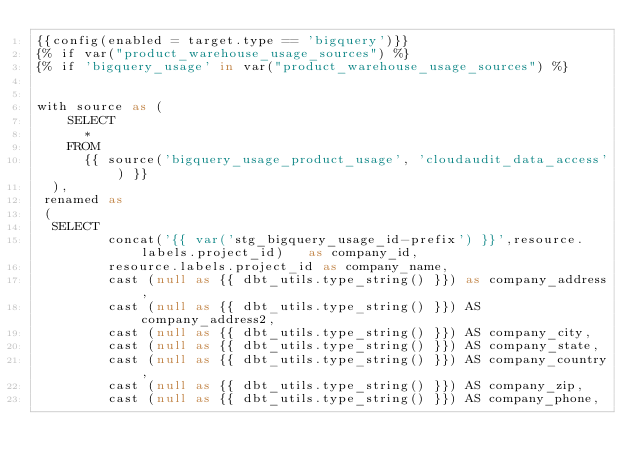<code> <loc_0><loc_0><loc_500><loc_500><_SQL_>{{config(enabled = target.type == 'bigquery')}}
{% if var("product_warehouse_usage_sources") %}
{% if 'bigquery_usage' in var("product_warehouse_usage_sources") %}


with source as (
    SELECT
      *
    FROM
      {{ source('bigquery_usage_product_usage', 'cloudaudit_data_access') }}
  ),
 renamed as
 (
  SELECT
         concat('{{ var('stg_bigquery_usage_id-prefix') }}',resource.labels.project_id)   as company_id,
         resource.labels.project_id as company_name,
         cast (null as {{ dbt_utils.type_string() }}) as company_address,
         cast (null as {{ dbt_utils.type_string() }}) AS company_address2,
         cast (null as {{ dbt_utils.type_string() }}) AS company_city,
         cast (null as {{ dbt_utils.type_string() }}) AS company_state,
         cast (null as {{ dbt_utils.type_string() }}) AS company_country,
         cast (null as {{ dbt_utils.type_string() }}) AS company_zip,
         cast (null as {{ dbt_utils.type_string() }}) AS company_phone,</code> 